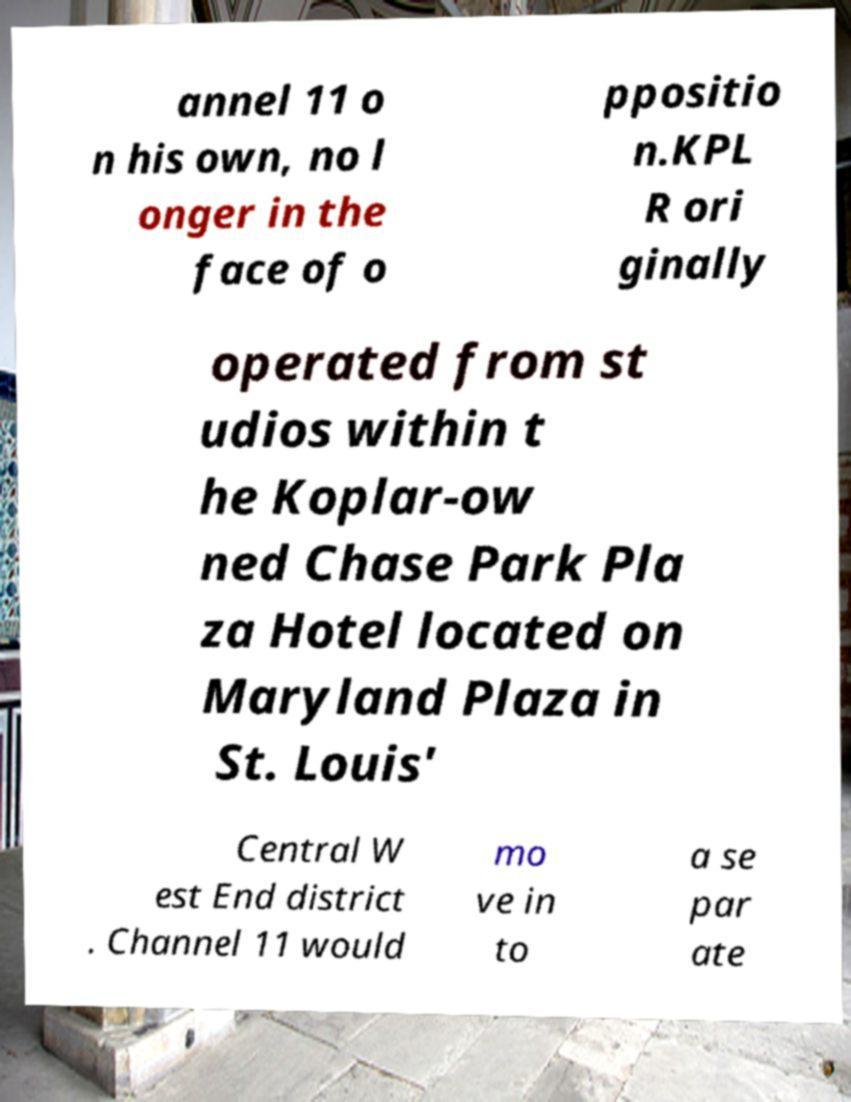I need the written content from this picture converted into text. Can you do that? annel 11 o n his own, no l onger in the face of o ppositio n.KPL R ori ginally operated from st udios within t he Koplar-ow ned Chase Park Pla za Hotel located on Maryland Plaza in St. Louis' Central W est End district . Channel 11 would mo ve in to a se par ate 